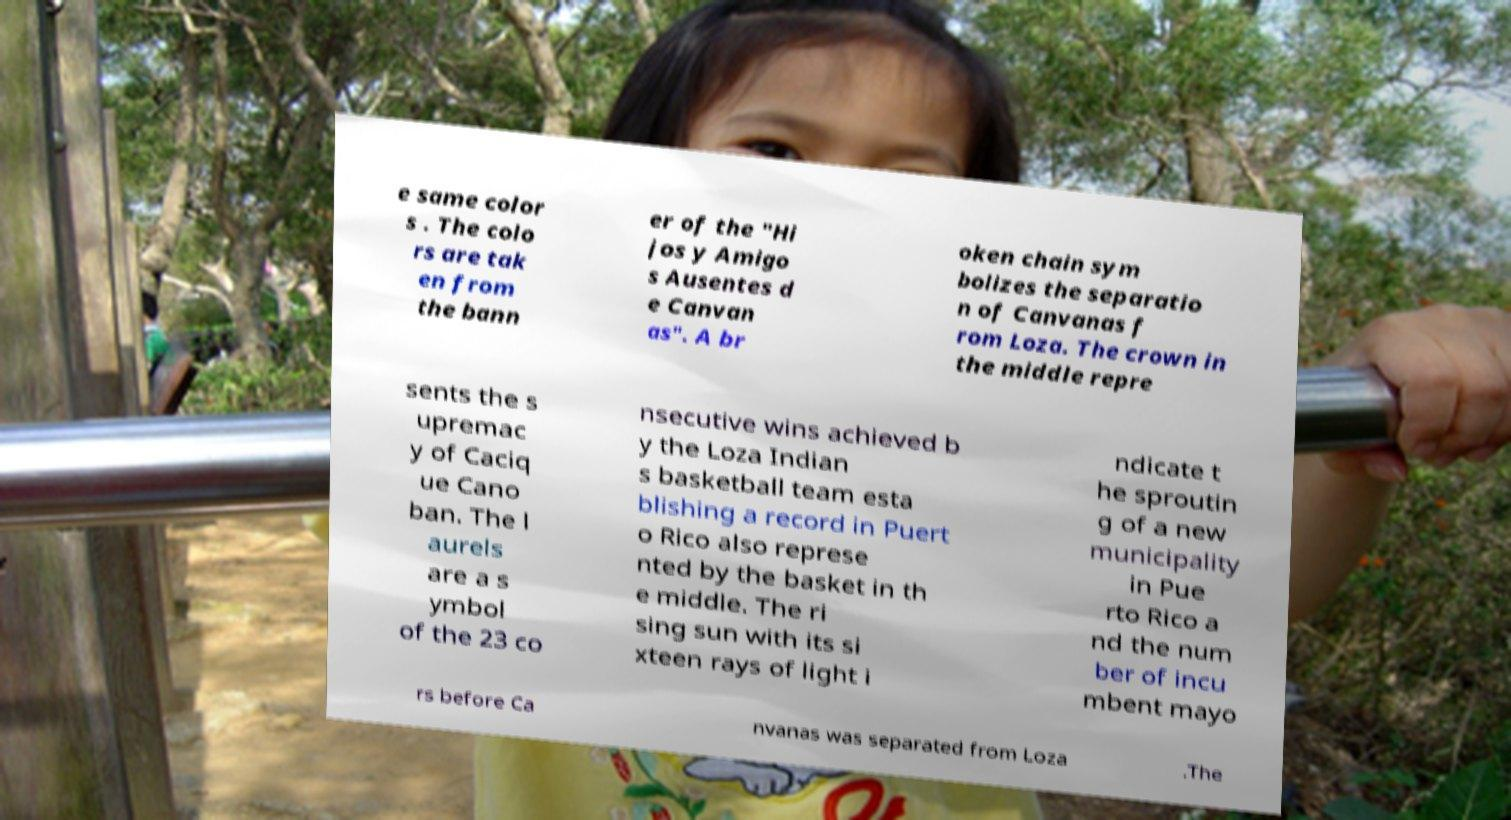I need the written content from this picture converted into text. Can you do that? e same color s . The colo rs are tak en from the bann er of the "Hi jos y Amigo s Ausentes d e Canvan as". A br oken chain sym bolizes the separatio n of Canvanas f rom Loza. The crown in the middle repre sents the s upremac y of Caciq ue Cano ban. The l aurels are a s ymbol of the 23 co nsecutive wins achieved b y the Loza Indian s basketball team esta blishing a record in Puert o Rico also represe nted by the basket in th e middle. The ri sing sun with its si xteen rays of light i ndicate t he sproutin g of a new municipality in Pue rto Rico a nd the num ber of incu mbent mayo rs before Ca nvanas was separated from Loza .The 